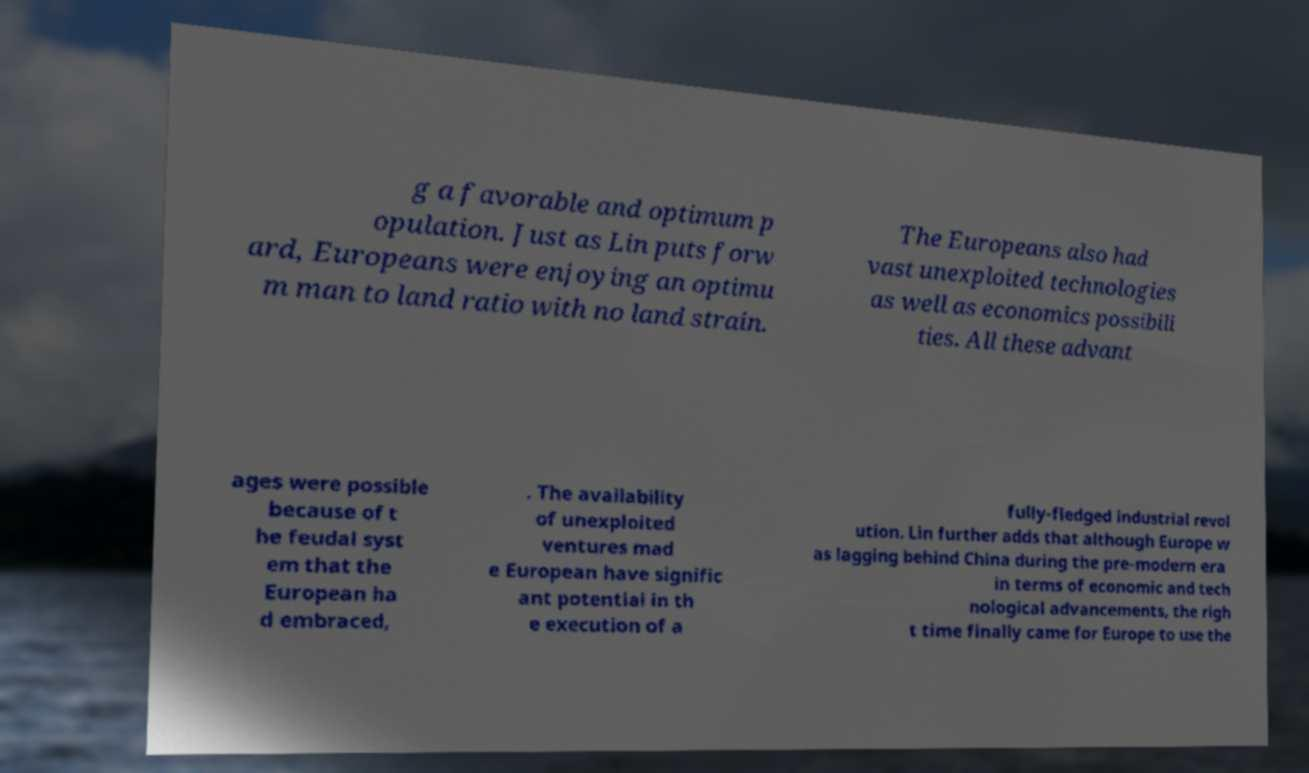Can you accurately transcribe the text from the provided image for me? g a favorable and optimum p opulation. Just as Lin puts forw ard, Europeans were enjoying an optimu m man to land ratio with no land strain. The Europeans also had vast unexploited technologies as well as economics possibili ties. All these advant ages were possible because of t he feudal syst em that the European ha d embraced, . The availability of unexploited ventures mad e European have signific ant potential in th e execution of a fully-fledged industrial revol ution. Lin further adds that although Europe w as lagging behind China during the pre-modern era in terms of economic and tech nological advancements, the righ t time finally came for Europe to use the 